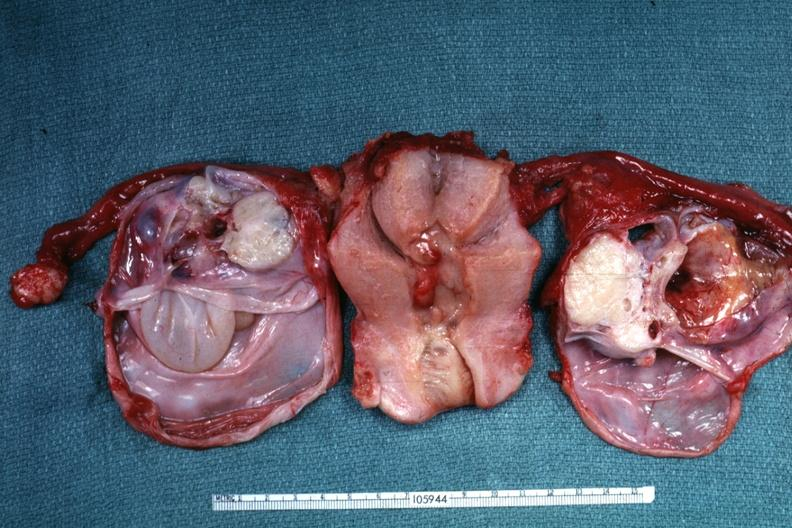have normal palmar creases been cut to show multiloculated nature of tumor masses?
Answer the question using a single word or phrase. No 